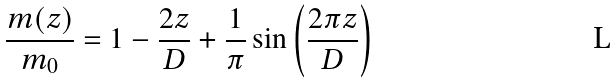Convert formula to latex. <formula><loc_0><loc_0><loc_500><loc_500>\frac { m ( z ) } { m _ { 0 } } = 1 - \frac { 2 z } { D } + \frac { 1 } { \pi } \sin \left ( \frac { 2 \pi z } { D } \right )</formula> 